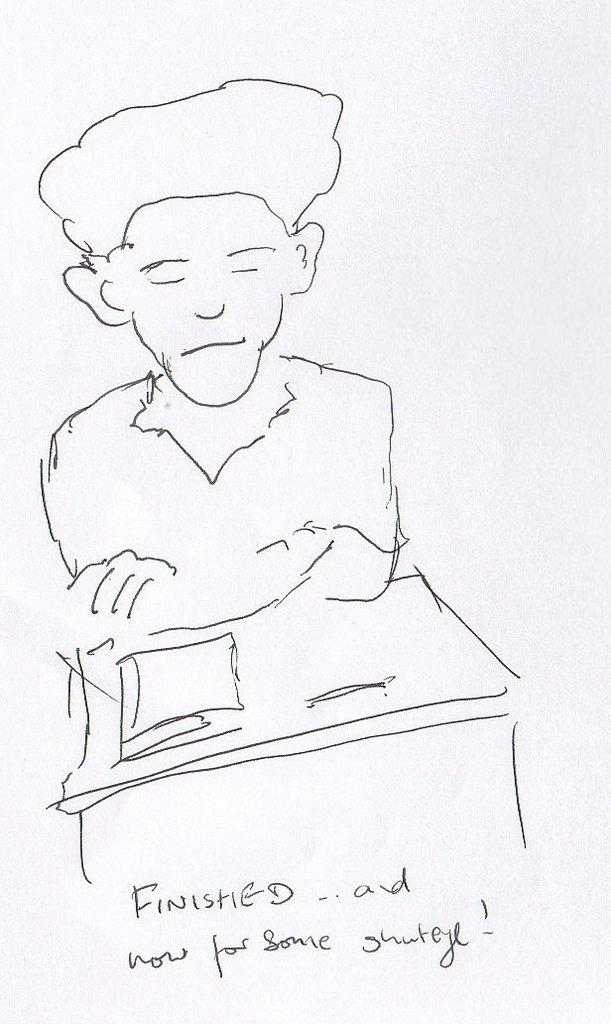What is the main subject of the image? There is a drawing of a person in the center of the image. Is there any text associated with the image? Yes, there is text at the bottom of the image. How much honey is in the can in the image? There is no can or honey present in the image; it features a drawing of a person and text at the bottom. 